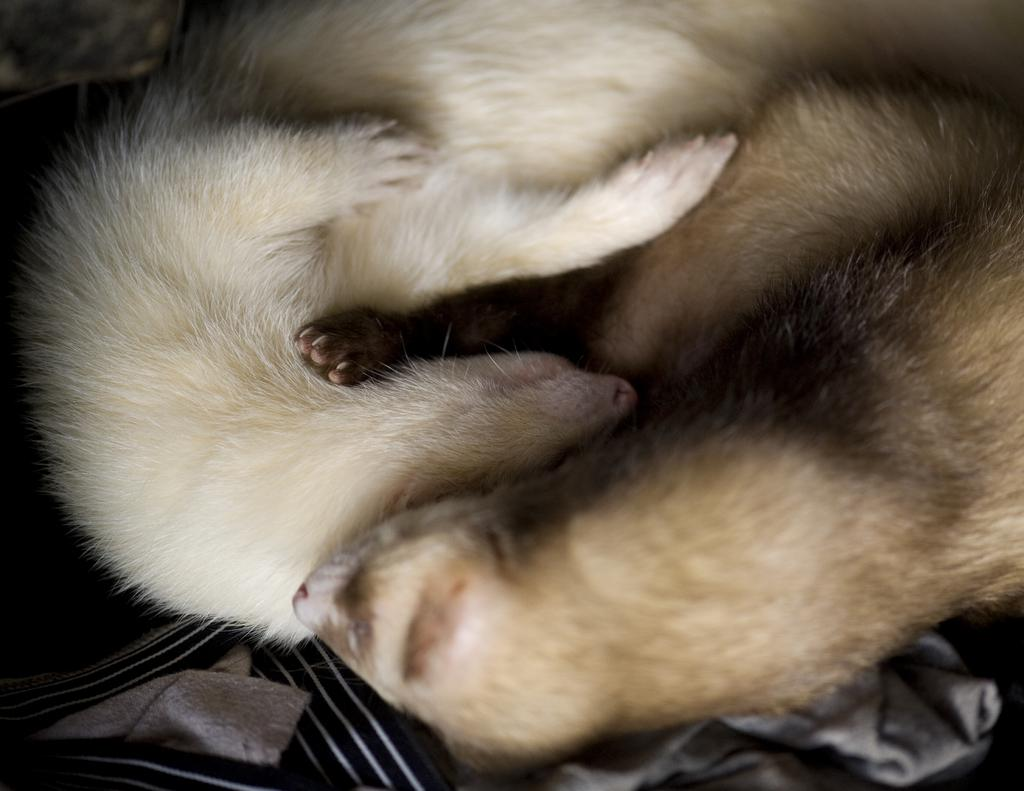What type of creature can be seen in the image? There is an animal in the image. Where is the animal positioned in the image? The animal is lying on a blanket. What type of quartz can be seen in the image? There is no quartz present in the image; it features an animal lying on a blanket. Can you provide an example of a branch in the image? There is no branch present in the image. 